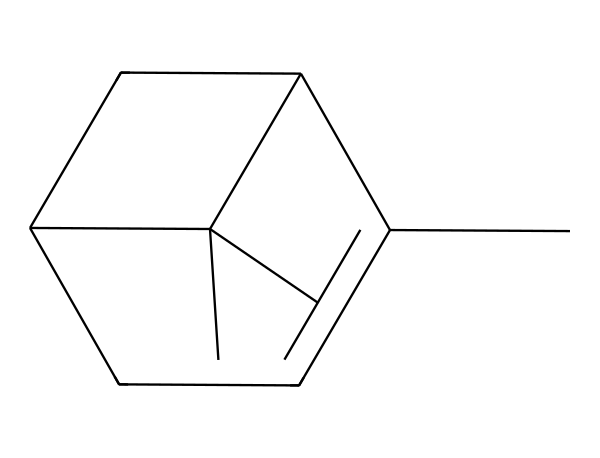What is the molecular formula of pinene? To find the molecular formula, we count the number of each type of atom in the SMILES representation. The SMILES contains 10 carbon (C) atoms and 16 hydrogen (H) atoms. Therefore, the molecular formula is C10H16.
Answer: C10H16 How many rings are present in the structure of pinene? By analyzing the structure, we observe that there are two ring systems connected through a carbon bond. Each ring consisting of multiple carbon atoms indicates that this compound has a bicyclic structure.
Answer: 2 What functional groups are present in pinene? Observing the structure of pinene, there are no hydroxyl (-OH), carboxyl (-COOH), or any other characteristic functional groups visible, indicating that pinene is a hydrocarbon terpene without any additional functional groups.
Answer: None Is pinene considered a saturated or unsaturated hydrocarbon? Pinene has double bonds present in its structure indicated by the arrangement of carbon atoms shown in the rings and between carbons. The presence of double bonds confirms that it is unsaturated.
Answer: Unsaturated What is the significance of pinene in eco-friendly fragrances? Pinene is prominently used in eco-friendly fragrances because it is a natural compound derived from pine trees. This natural origin aligns with sustainable development goals, promoting the use of renewable resources in consumer products.
Answer: Natural compound Is pinene a structural isomer of another terpene? Yes, pinene has structural isomers such as α-pinene and β-pinene, which differ in the arrangement of the double bonds and carbon ring structures, indicating that it belongs to a larger family of terpenes with similar molecular formulas.
Answer: Yes 